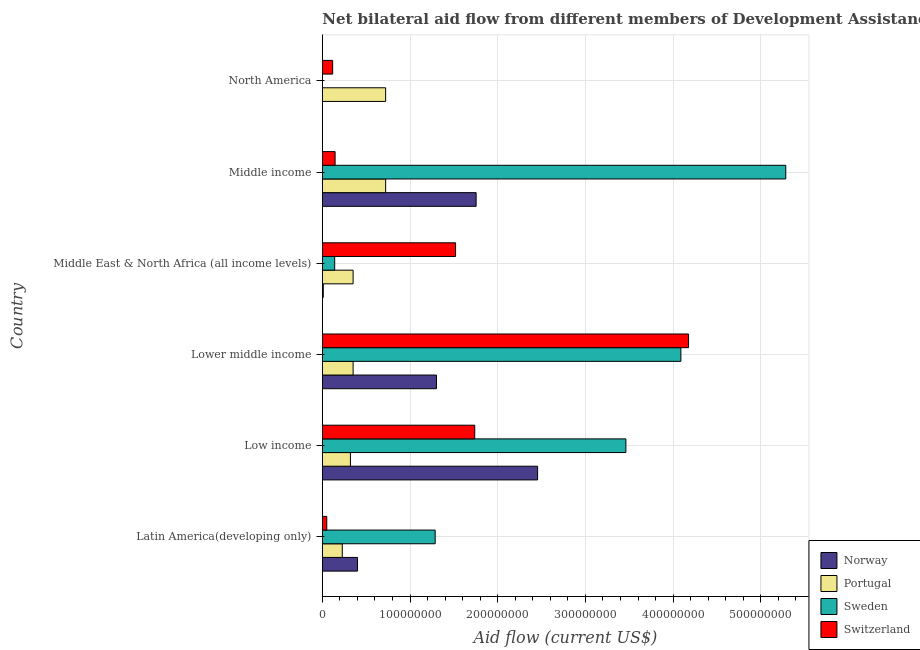How many different coloured bars are there?
Your response must be concise. 4. How many groups of bars are there?
Provide a succinct answer. 6. Are the number of bars per tick equal to the number of legend labels?
Your response must be concise. No. Are the number of bars on each tick of the Y-axis equal?
Keep it short and to the point. No. How many bars are there on the 2nd tick from the top?
Keep it short and to the point. 4. What is the label of the 4th group of bars from the top?
Make the answer very short. Lower middle income. What is the amount of aid given by switzerland in Lower middle income?
Provide a short and direct response. 4.18e+08. Across all countries, what is the maximum amount of aid given by portugal?
Offer a terse response. 7.22e+07. Across all countries, what is the minimum amount of aid given by portugal?
Ensure brevity in your answer.  2.28e+07. In which country was the amount of aid given by norway maximum?
Offer a very short reply. Low income. What is the total amount of aid given by norway in the graph?
Offer a terse response. 5.92e+08. What is the difference between the amount of aid given by portugal in Middle East & North Africa (all income levels) and that in North America?
Your answer should be very brief. -3.71e+07. What is the difference between the amount of aid given by switzerland in Middle income and the amount of aid given by norway in Low income?
Provide a short and direct response. -2.31e+08. What is the average amount of aid given by portugal per country?
Offer a very short reply. 4.49e+07. What is the difference between the amount of aid given by sweden and amount of aid given by switzerland in Middle East & North Africa (all income levels)?
Keep it short and to the point. -1.38e+08. In how many countries, is the amount of aid given by switzerland greater than 440000000 US$?
Provide a succinct answer. 0. What is the ratio of the amount of aid given by switzerland in Latin America(developing only) to that in Lower middle income?
Your answer should be compact. 0.01. Is the amount of aid given by portugal in Lower middle income less than that in Middle East & North Africa (all income levels)?
Provide a succinct answer. No. What is the difference between the highest and the second highest amount of aid given by switzerland?
Your answer should be compact. 2.44e+08. What is the difference between the highest and the lowest amount of aid given by norway?
Your answer should be very brief. 2.45e+08. In how many countries, is the amount of aid given by sweden greater than the average amount of aid given by sweden taken over all countries?
Provide a succinct answer. 3. Is it the case that in every country, the sum of the amount of aid given by norway and amount of aid given by portugal is greater than the amount of aid given by sweden?
Offer a terse response. No. Does the graph contain any zero values?
Make the answer very short. Yes. Does the graph contain grids?
Provide a succinct answer. Yes. What is the title of the graph?
Make the answer very short. Net bilateral aid flow from different members of Development Assistance Committee in the year 1989. Does "Forest" appear as one of the legend labels in the graph?
Your response must be concise. No. What is the label or title of the X-axis?
Your answer should be compact. Aid flow (current US$). What is the label or title of the Y-axis?
Your response must be concise. Country. What is the Aid flow (current US$) in Norway in Latin America(developing only)?
Ensure brevity in your answer.  4.01e+07. What is the Aid flow (current US$) in Portugal in Latin America(developing only)?
Your response must be concise. 2.28e+07. What is the Aid flow (current US$) in Sweden in Latin America(developing only)?
Give a very brief answer. 1.29e+08. What is the Aid flow (current US$) in Switzerland in Latin America(developing only)?
Provide a succinct answer. 5.06e+06. What is the Aid flow (current US$) in Norway in Low income?
Your answer should be very brief. 2.45e+08. What is the Aid flow (current US$) in Portugal in Low income?
Offer a very short reply. 3.21e+07. What is the Aid flow (current US$) in Sweden in Low income?
Your answer should be compact. 3.46e+08. What is the Aid flow (current US$) in Switzerland in Low income?
Provide a succinct answer. 1.74e+08. What is the Aid flow (current US$) in Norway in Lower middle income?
Provide a short and direct response. 1.30e+08. What is the Aid flow (current US$) of Portugal in Lower middle income?
Ensure brevity in your answer.  3.51e+07. What is the Aid flow (current US$) of Sweden in Lower middle income?
Provide a succinct answer. 4.09e+08. What is the Aid flow (current US$) of Switzerland in Lower middle income?
Offer a very short reply. 4.18e+08. What is the Aid flow (current US$) of Norway in Middle East & North Africa (all income levels)?
Ensure brevity in your answer.  1.06e+06. What is the Aid flow (current US$) of Portugal in Middle East & North Africa (all income levels)?
Ensure brevity in your answer.  3.51e+07. What is the Aid flow (current US$) of Sweden in Middle East & North Africa (all income levels)?
Provide a succinct answer. 1.41e+07. What is the Aid flow (current US$) of Switzerland in Middle East & North Africa (all income levels)?
Your answer should be very brief. 1.52e+08. What is the Aid flow (current US$) of Norway in Middle income?
Offer a very short reply. 1.75e+08. What is the Aid flow (current US$) of Portugal in Middle income?
Provide a short and direct response. 7.22e+07. What is the Aid flow (current US$) of Sweden in Middle income?
Provide a succinct answer. 5.29e+08. What is the Aid flow (current US$) of Switzerland in Middle income?
Give a very brief answer. 1.46e+07. What is the Aid flow (current US$) of Norway in North America?
Offer a very short reply. 3.00e+04. What is the Aid flow (current US$) in Portugal in North America?
Your answer should be very brief. 7.22e+07. What is the Aid flow (current US$) in Switzerland in North America?
Keep it short and to the point. 1.18e+07. Across all countries, what is the maximum Aid flow (current US$) in Norway?
Provide a succinct answer. 2.45e+08. Across all countries, what is the maximum Aid flow (current US$) of Portugal?
Provide a short and direct response. 7.22e+07. Across all countries, what is the maximum Aid flow (current US$) in Sweden?
Offer a terse response. 5.29e+08. Across all countries, what is the maximum Aid flow (current US$) of Switzerland?
Your response must be concise. 4.18e+08. Across all countries, what is the minimum Aid flow (current US$) of Norway?
Make the answer very short. 3.00e+04. Across all countries, what is the minimum Aid flow (current US$) in Portugal?
Your answer should be very brief. 2.28e+07. Across all countries, what is the minimum Aid flow (current US$) in Sweden?
Provide a short and direct response. 0. Across all countries, what is the minimum Aid flow (current US$) in Switzerland?
Keep it short and to the point. 5.06e+06. What is the total Aid flow (current US$) in Norway in the graph?
Offer a very short reply. 5.92e+08. What is the total Aid flow (current US$) in Portugal in the graph?
Make the answer very short. 2.69e+08. What is the total Aid flow (current US$) in Sweden in the graph?
Provide a succinct answer. 1.43e+09. What is the total Aid flow (current US$) in Switzerland in the graph?
Give a very brief answer. 7.75e+08. What is the difference between the Aid flow (current US$) in Norway in Latin America(developing only) and that in Low income?
Make the answer very short. -2.05e+08. What is the difference between the Aid flow (current US$) in Portugal in Latin America(developing only) and that in Low income?
Offer a very short reply. -9.30e+06. What is the difference between the Aid flow (current US$) of Sweden in Latin America(developing only) and that in Low income?
Provide a succinct answer. -2.17e+08. What is the difference between the Aid flow (current US$) in Switzerland in Latin America(developing only) and that in Low income?
Keep it short and to the point. -1.69e+08. What is the difference between the Aid flow (current US$) in Norway in Latin America(developing only) and that in Lower middle income?
Offer a terse response. -9.01e+07. What is the difference between the Aid flow (current US$) in Portugal in Latin America(developing only) and that in Lower middle income?
Your response must be concise. -1.23e+07. What is the difference between the Aid flow (current US$) in Sweden in Latin America(developing only) and that in Lower middle income?
Provide a short and direct response. -2.80e+08. What is the difference between the Aid flow (current US$) of Switzerland in Latin America(developing only) and that in Lower middle income?
Give a very brief answer. -4.13e+08. What is the difference between the Aid flow (current US$) of Norway in Latin America(developing only) and that in Middle East & North Africa (all income levels)?
Ensure brevity in your answer.  3.90e+07. What is the difference between the Aid flow (current US$) in Portugal in Latin America(developing only) and that in Middle East & North Africa (all income levels)?
Your answer should be compact. -1.23e+07. What is the difference between the Aid flow (current US$) of Sweden in Latin America(developing only) and that in Middle East & North Africa (all income levels)?
Make the answer very short. 1.15e+08. What is the difference between the Aid flow (current US$) of Switzerland in Latin America(developing only) and that in Middle East & North Africa (all income levels)?
Provide a succinct answer. -1.47e+08. What is the difference between the Aid flow (current US$) of Norway in Latin America(developing only) and that in Middle income?
Give a very brief answer. -1.35e+08. What is the difference between the Aid flow (current US$) in Portugal in Latin America(developing only) and that in Middle income?
Give a very brief answer. -4.94e+07. What is the difference between the Aid flow (current US$) in Sweden in Latin America(developing only) and that in Middle income?
Ensure brevity in your answer.  -4.00e+08. What is the difference between the Aid flow (current US$) of Switzerland in Latin America(developing only) and that in Middle income?
Offer a very short reply. -9.50e+06. What is the difference between the Aid flow (current US$) in Norway in Latin America(developing only) and that in North America?
Offer a terse response. 4.01e+07. What is the difference between the Aid flow (current US$) of Portugal in Latin America(developing only) and that in North America?
Provide a succinct answer. -4.94e+07. What is the difference between the Aid flow (current US$) in Switzerland in Latin America(developing only) and that in North America?
Make the answer very short. -6.72e+06. What is the difference between the Aid flow (current US$) in Norway in Low income and that in Lower middle income?
Provide a short and direct response. 1.15e+08. What is the difference between the Aid flow (current US$) of Portugal in Low income and that in Lower middle income?
Your answer should be very brief. -3.04e+06. What is the difference between the Aid flow (current US$) of Sweden in Low income and that in Lower middle income?
Your answer should be compact. -6.27e+07. What is the difference between the Aid flow (current US$) of Switzerland in Low income and that in Lower middle income?
Offer a terse response. -2.44e+08. What is the difference between the Aid flow (current US$) in Norway in Low income and that in Middle East & North Africa (all income levels)?
Offer a terse response. 2.44e+08. What is the difference between the Aid flow (current US$) in Portugal in Low income and that in Middle East & North Africa (all income levels)?
Ensure brevity in your answer.  -3.04e+06. What is the difference between the Aid flow (current US$) of Sweden in Low income and that in Middle East & North Africa (all income levels)?
Provide a succinct answer. 3.32e+08. What is the difference between the Aid flow (current US$) of Switzerland in Low income and that in Middle East & North Africa (all income levels)?
Provide a succinct answer. 2.18e+07. What is the difference between the Aid flow (current US$) of Norway in Low income and that in Middle income?
Offer a very short reply. 7.01e+07. What is the difference between the Aid flow (current US$) in Portugal in Low income and that in Middle income?
Your response must be concise. -4.01e+07. What is the difference between the Aid flow (current US$) of Sweden in Low income and that in Middle income?
Offer a terse response. -1.82e+08. What is the difference between the Aid flow (current US$) of Switzerland in Low income and that in Middle income?
Keep it short and to the point. 1.59e+08. What is the difference between the Aid flow (current US$) of Norway in Low income and that in North America?
Ensure brevity in your answer.  2.45e+08. What is the difference between the Aid flow (current US$) of Portugal in Low income and that in North America?
Provide a short and direct response. -4.01e+07. What is the difference between the Aid flow (current US$) in Switzerland in Low income and that in North America?
Keep it short and to the point. 1.62e+08. What is the difference between the Aid flow (current US$) in Norway in Lower middle income and that in Middle East & North Africa (all income levels)?
Provide a short and direct response. 1.29e+08. What is the difference between the Aid flow (current US$) in Sweden in Lower middle income and that in Middle East & North Africa (all income levels)?
Your answer should be compact. 3.95e+08. What is the difference between the Aid flow (current US$) of Switzerland in Lower middle income and that in Middle East & North Africa (all income levels)?
Ensure brevity in your answer.  2.66e+08. What is the difference between the Aid flow (current US$) of Norway in Lower middle income and that in Middle income?
Offer a very short reply. -4.52e+07. What is the difference between the Aid flow (current US$) in Portugal in Lower middle income and that in Middle income?
Offer a terse response. -3.71e+07. What is the difference between the Aid flow (current US$) of Sweden in Lower middle income and that in Middle income?
Provide a short and direct response. -1.20e+08. What is the difference between the Aid flow (current US$) in Switzerland in Lower middle income and that in Middle income?
Provide a short and direct response. 4.03e+08. What is the difference between the Aid flow (current US$) of Norway in Lower middle income and that in North America?
Your response must be concise. 1.30e+08. What is the difference between the Aid flow (current US$) of Portugal in Lower middle income and that in North America?
Provide a short and direct response. -3.71e+07. What is the difference between the Aid flow (current US$) of Switzerland in Lower middle income and that in North America?
Your answer should be compact. 4.06e+08. What is the difference between the Aid flow (current US$) of Norway in Middle East & North Africa (all income levels) and that in Middle income?
Provide a succinct answer. -1.74e+08. What is the difference between the Aid flow (current US$) of Portugal in Middle East & North Africa (all income levels) and that in Middle income?
Offer a very short reply. -3.71e+07. What is the difference between the Aid flow (current US$) in Sweden in Middle East & North Africa (all income levels) and that in Middle income?
Ensure brevity in your answer.  -5.14e+08. What is the difference between the Aid flow (current US$) of Switzerland in Middle East & North Africa (all income levels) and that in Middle income?
Give a very brief answer. 1.37e+08. What is the difference between the Aid flow (current US$) of Norway in Middle East & North Africa (all income levels) and that in North America?
Your answer should be very brief. 1.03e+06. What is the difference between the Aid flow (current US$) in Portugal in Middle East & North Africa (all income levels) and that in North America?
Your answer should be very brief. -3.71e+07. What is the difference between the Aid flow (current US$) in Switzerland in Middle East & North Africa (all income levels) and that in North America?
Your response must be concise. 1.40e+08. What is the difference between the Aid flow (current US$) in Norway in Middle income and that in North America?
Offer a terse response. 1.75e+08. What is the difference between the Aid flow (current US$) of Portugal in Middle income and that in North America?
Give a very brief answer. 0. What is the difference between the Aid flow (current US$) of Switzerland in Middle income and that in North America?
Your response must be concise. 2.78e+06. What is the difference between the Aid flow (current US$) in Norway in Latin America(developing only) and the Aid flow (current US$) in Portugal in Low income?
Offer a very short reply. 8.04e+06. What is the difference between the Aid flow (current US$) in Norway in Latin America(developing only) and the Aid flow (current US$) in Sweden in Low income?
Offer a terse response. -3.06e+08. What is the difference between the Aid flow (current US$) of Norway in Latin America(developing only) and the Aid flow (current US$) of Switzerland in Low income?
Your response must be concise. -1.34e+08. What is the difference between the Aid flow (current US$) of Portugal in Latin America(developing only) and the Aid flow (current US$) of Sweden in Low income?
Provide a succinct answer. -3.23e+08. What is the difference between the Aid flow (current US$) in Portugal in Latin America(developing only) and the Aid flow (current US$) in Switzerland in Low income?
Your answer should be compact. -1.51e+08. What is the difference between the Aid flow (current US$) in Sweden in Latin America(developing only) and the Aid flow (current US$) in Switzerland in Low income?
Give a very brief answer. -4.51e+07. What is the difference between the Aid flow (current US$) of Norway in Latin America(developing only) and the Aid flow (current US$) of Sweden in Lower middle income?
Offer a terse response. -3.69e+08. What is the difference between the Aid flow (current US$) in Norway in Latin America(developing only) and the Aid flow (current US$) in Switzerland in Lower middle income?
Offer a terse response. -3.78e+08. What is the difference between the Aid flow (current US$) of Portugal in Latin America(developing only) and the Aid flow (current US$) of Sweden in Lower middle income?
Your response must be concise. -3.86e+08. What is the difference between the Aid flow (current US$) in Portugal in Latin America(developing only) and the Aid flow (current US$) in Switzerland in Lower middle income?
Your answer should be very brief. -3.95e+08. What is the difference between the Aid flow (current US$) of Sweden in Latin America(developing only) and the Aid flow (current US$) of Switzerland in Lower middle income?
Your answer should be very brief. -2.89e+08. What is the difference between the Aid flow (current US$) in Norway in Latin America(developing only) and the Aid flow (current US$) in Sweden in Middle East & North Africa (all income levels)?
Provide a succinct answer. 2.60e+07. What is the difference between the Aid flow (current US$) in Norway in Latin America(developing only) and the Aid flow (current US$) in Switzerland in Middle East & North Africa (all income levels)?
Provide a succinct answer. -1.12e+08. What is the difference between the Aid flow (current US$) of Portugal in Latin America(developing only) and the Aid flow (current US$) of Sweden in Middle East & North Africa (all income levels)?
Provide a short and direct response. 8.66e+06. What is the difference between the Aid flow (current US$) of Portugal in Latin America(developing only) and the Aid flow (current US$) of Switzerland in Middle East & North Africa (all income levels)?
Your answer should be compact. -1.29e+08. What is the difference between the Aid flow (current US$) of Sweden in Latin America(developing only) and the Aid flow (current US$) of Switzerland in Middle East & North Africa (all income levels)?
Offer a terse response. -2.33e+07. What is the difference between the Aid flow (current US$) in Norway in Latin America(developing only) and the Aid flow (current US$) in Portugal in Middle income?
Keep it short and to the point. -3.21e+07. What is the difference between the Aid flow (current US$) in Norway in Latin America(developing only) and the Aid flow (current US$) in Sweden in Middle income?
Your response must be concise. -4.88e+08. What is the difference between the Aid flow (current US$) of Norway in Latin America(developing only) and the Aid flow (current US$) of Switzerland in Middle income?
Make the answer very short. 2.55e+07. What is the difference between the Aid flow (current US$) of Portugal in Latin America(developing only) and the Aid flow (current US$) of Sweden in Middle income?
Keep it short and to the point. -5.06e+08. What is the difference between the Aid flow (current US$) of Portugal in Latin America(developing only) and the Aid flow (current US$) of Switzerland in Middle income?
Offer a terse response. 8.20e+06. What is the difference between the Aid flow (current US$) of Sweden in Latin America(developing only) and the Aid flow (current US$) of Switzerland in Middle income?
Offer a terse response. 1.14e+08. What is the difference between the Aid flow (current US$) in Norway in Latin America(developing only) and the Aid flow (current US$) in Portugal in North America?
Keep it short and to the point. -3.21e+07. What is the difference between the Aid flow (current US$) of Norway in Latin America(developing only) and the Aid flow (current US$) of Switzerland in North America?
Make the answer very short. 2.83e+07. What is the difference between the Aid flow (current US$) of Portugal in Latin America(developing only) and the Aid flow (current US$) of Switzerland in North America?
Ensure brevity in your answer.  1.10e+07. What is the difference between the Aid flow (current US$) in Sweden in Latin America(developing only) and the Aid flow (current US$) in Switzerland in North America?
Ensure brevity in your answer.  1.17e+08. What is the difference between the Aid flow (current US$) in Norway in Low income and the Aid flow (current US$) in Portugal in Lower middle income?
Make the answer very short. 2.10e+08. What is the difference between the Aid flow (current US$) in Norway in Low income and the Aid flow (current US$) in Sweden in Lower middle income?
Offer a terse response. -1.63e+08. What is the difference between the Aid flow (current US$) of Norway in Low income and the Aid flow (current US$) of Switzerland in Lower middle income?
Your response must be concise. -1.72e+08. What is the difference between the Aid flow (current US$) of Portugal in Low income and the Aid flow (current US$) of Sweden in Lower middle income?
Keep it short and to the point. -3.77e+08. What is the difference between the Aid flow (current US$) in Portugal in Low income and the Aid flow (current US$) in Switzerland in Lower middle income?
Ensure brevity in your answer.  -3.86e+08. What is the difference between the Aid flow (current US$) in Sweden in Low income and the Aid flow (current US$) in Switzerland in Lower middle income?
Provide a short and direct response. -7.15e+07. What is the difference between the Aid flow (current US$) of Norway in Low income and the Aid flow (current US$) of Portugal in Middle East & North Africa (all income levels)?
Provide a succinct answer. 2.10e+08. What is the difference between the Aid flow (current US$) in Norway in Low income and the Aid flow (current US$) in Sweden in Middle East & North Africa (all income levels)?
Ensure brevity in your answer.  2.31e+08. What is the difference between the Aid flow (current US$) of Norway in Low income and the Aid flow (current US$) of Switzerland in Middle East & North Africa (all income levels)?
Ensure brevity in your answer.  9.35e+07. What is the difference between the Aid flow (current US$) of Portugal in Low income and the Aid flow (current US$) of Sweden in Middle East & North Africa (all income levels)?
Offer a terse response. 1.80e+07. What is the difference between the Aid flow (current US$) of Portugal in Low income and the Aid flow (current US$) of Switzerland in Middle East & North Africa (all income levels)?
Keep it short and to the point. -1.20e+08. What is the difference between the Aid flow (current US$) in Sweden in Low income and the Aid flow (current US$) in Switzerland in Middle East & North Africa (all income levels)?
Keep it short and to the point. 1.94e+08. What is the difference between the Aid flow (current US$) in Norway in Low income and the Aid flow (current US$) in Portugal in Middle income?
Make the answer very short. 1.73e+08. What is the difference between the Aid flow (current US$) of Norway in Low income and the Aid flow (current US$) of Sweden in Middle income?
Make the answer very short. -2.83e+08. What is the difference between the Aid flow (current US$) in Norway in Low income and the Aid flow (current US$) in Switzerland in Middle income?
Your response must be concise. 2.31e+08. What is the difference between the Aid flow (current US$) in Portugal in Low income and the Aid flow (current US$) in Sweden in Middle income?
Ensure brevity in your answer.  -4.96e+08. What is the difference between the Aid flow (current US$) in Portugal in Low income and the Aid flow (current US$) in Switzerland in Middle income?
Your response must be concise. 1.75e+07. What is the difference between the Aid flow (current US$) of Sweden in Low income and the Aid flow (current US$) of Switzerland in Middle income?
Offer a terse response. 3.32e+08. What is the difference between the Aid flow (current US$) of Norway in Low income and the Aid flow (current US$) of Portugal in North America?
Keep it short and to the point. 1.73e+08. What is the difference between the Aid flow (current US$) in Norway in Low income and the Aid flow (current US$) in Switzerland in North America?
Offer a terse response. 2.34e+08. What is the difference between the Aid flow (current US$) of Portugal in Low income and the Aid flow (current US$) of Switzerland in North America?
Your answer should be compact. 2.03e+07. What is the difference between the Aid flow (current US$) in Sweden in Low income and the Aid flow (current US$) in Switzerland in North America?
Make the answer very short. 3.34e+08. What is the difference between the Aid flow (current US$) of Norway in Lower middle income and the Aid flow (current US$) of Portugal in Middle East & North Africa (all income levels)?
Ensure brevity in your answer.  9.51e+07. What is the difference between the Aid flow (current US$) in Norway in Lower middle income and the Aid flow (current US$) in Sweden in Middle East & North Africa (all income levels)?
Ensure brevity in your answer.  1.16e+08. What is the difference between the Aid flow (current US$) of Norway in Lower middle income and the Aid flow (current US$) of Switzerland in Middle East & North Africa (all income levels)?
Offer a very short reply. -2.18e+07. What is the difference between the Aid flow (current US$) in Portugal in Lower middle income and the Aid flow (current US$) in Sweden in Middle East & North Africa (all income levels)?
Your response must be concise. 2.10e+07. What is the difference between the Aid flow (current US$) of Portugal in Lower middle income and the Aid flow (current US$) of Switzerland in Middle East & North Africa (all income levels)?
Offer a very short reply. -1.17e+08. What is the difference between the Aid flow (current US$) of Sweden in Lower middle income and the Aid flow (current US$) of Switzerland in Middle East & North Africa (all income levels)?
Give a very brief answer. 2.57e+08. What is the difference between the Aid flow (current US$) of Norway in Lower middle income and the Aid flow (current US$) of Portugal in Middle income?
Ensure brevity in your answer.  5.80e+07. What is the difference between the Aid flow (current US$) in Norway in Lower middle income and the Aid flow (current US$) in Sweden in Middle income?
Offer a very short reply. -3.98e+08. What is the difference between the Aid flow (current US$) of Norway in Lower middle income and the Aid flow (current US$) of Switzerland in Middle income?
Offer a terse response. 1.16e+08. What is the difference between the Aid flow (current US$) in Portugal in Lower middle income and the Aid flow (current US$) in Sweden in Middle income?
Offer a terse response. -4.93e+08. What is the difference between the Aid flow (current US$) of Portugal in Lower middle income and the Aid flow (current US$) of Switzerland in Middle income?
Your answer should be compact. 2.05e+07. What is the difference between the Aid flow (current US$) of Sweden in Lower middle income and the Aid flow (current US$) of Switzerland in Middle income?
Provide a short and direct response. 3.94e+08. What is the difference between the Aid flow (current US$) of Norway in Lower middle income and the Aid flow (current US$) of Portugal in North America?
Your answer should be compact. 5.80e+07. What is the difference between the Aid flow (current US$) of Norway in Lower middle income and the Aid flow (current US$) of Switzerland in North America?
Offer a very short reply. 1.18e+08. What is the difference between the Aid flow (current US$) in Portugal in Lower middle income and the Aid flow (current US$) in Switzerland in North America?
Ensure brevity in your answer.  2.33e+07. What is the difference between the Aid flow (current US$) of Sweden in Lower middle income and the Aid flow (current US$) of Switzerland in North America?
Provide a short and direct response. 3.97e+08. What is the difference between the Aid flow (current US$) of Norway in Middle East & North Africa (all income levels) and the Aid flow (current US$) of Portugal in Middle income?
Provide a succinct answer. -7.11e+07. What is the difference between the Aid flow (current US$) of Norway in Middle East & North Africa (all income levels) and the Aid flow (current US$) of Sweden in Middle income?
Offer a very short reply. -5.27e+08. What is the difference between the Aid flow (current US$) in Norway in Middle East & North Africa (all income levels) and the Aid flow (current US$) in Switzerland in Middle income?
Your answer should be very brief. -1.35e+07. What is the difference between the Aid flow (current US$) in Portugal in Middle East & North Africa (all income levels) and the Aid flow (current US$) in Sweden in Middle income?
Your answer should be compact. -4.93e+08. What is the difference between the Aid flow (current US$) of Portugal in Middle East & North Africa (all income levels) and the Aid flow (current US$) of Switzerland in Middle income?
Ensure brevity in your answer.  2.05e+07. What is the difference between the Aid flow (current US$) in Sweden in Middle East & North Africa (all income levels) and the Aid flow (current US$) in Switzerland in Middle income?
Offer a terse response. -4.60e+05. What is the difference between the Aid flow (current US$) of Norway in Middle East & North Africa (all income levels) and the Aid flow (current US$) of Portugal in North America?
Your answer should be compact. -7.11e+07. What is the difference between the Aid flow (current US$) of Norway in Middle East & North Africa (all income levels) and the Aid flow (current US$) of Switzerland in North America?
Your response must be concise. -1.07e+07. What is the difference between the Aid flow (current US$) of Portugal in Middle East & North Africa (all income levels) and the Aid flow (current US$) of Switzerland in North America?
Ensure brevity in your answer.  2.33e+07. What is the difference between the Aid flow (current US$) of Sweden in Middle East & North Africa (all income levels) and the Aid flow (current US$) of Switzerland in North America?
Give a very brief answer. 2.32e+06. What is the difference between the Aid flow (current US$) in Norway in Middle income and the Aid flow (current US$) in Portugal in North America?
Offer a terse response. 1.03e+08. What is the difference between the Aid flow (current US$) in Norway in Middle income and the Aid flow (current US$) in Switzerland in North America?
Make the answer very short. 1.64e+08. What is the difference between the Aid flow (current US$) in Portugal in Middle income and the Aid flow (current US$) in Switzerland in North America?
Your response must be concise. 6.04e+07. What is the difference between the Aid flow (current US$) in Sweden in Middle income and the Aid flow (current US$) in Switzerland in North America?
Your answer should be compact. 5.17e+08. What is the average Aid flow (current US$) of Norway per country?
Offer a very short reply. 9.87e+07. What is the average Aid flow (current US$) of Portugal per country?
Offer a very short reply. 4.49e+07. What is the average Aid flow (current US$) in Sweden per country?
Your response must be concise. 2.38e+08. What is the average Aid flow (current US$) of Switzerland per country?
Keep it short and to the point. 1.29e+08. What is the difference between the Aid flow (current US$) in Norway and Aid flow (current US$) in Portugal in Latin America(developing only)?
Offer a very short reply. 1.73e+07. What is the difference between the Aid flow (current US$) in Norway and Aid flow (current US$) in Sweden in Latin America(developing only)?
Provide a short and direct response. -8.86e+07. What is the difference between the Aid flow (current US$) of Norway and Aid flow (current US$) of Switzerland in Latin America(developing only)?
Give a very brief answer. 3.50e+07. What is the difference between the Aid flow (current US$) in Portugal and Aid flow (current US$) in Sweden in Latin America(developing only)?
Ensure brevity in your answer.  -1.06e+08. What is the difference between the Aid flow (current US$) of Portugal and Aid flow (current US$) of Switzerland in Latin America(developing only)?
Offer a very short reply. 1.77e+07. What is the difference between the Aid flow (current US$) of Sweden and Aid flow (current US$) of Switzerland in Latin America(developing only)?
Provide a short and direct response. 1.24e+08. What is the difference between the Aid flow (current US$) of Norway and Aid flow (current US$) of Portugal in Low income?
Your response must be concise. 2.13e+08. What is the difference between the Aid flow (current US$) in Norway and Aid flow (current US$) in Sweden in Low income?
Provide a succinct answer. -1.01e+08. What is the difference between the Aid flow (current US$) of Norway and Aid flow (current US$) of Switzerland in Low income?
Make the answer very short. 7.17e+07. What is the difference between the Aid flow (current US$) in Portugal and Aid flow (current US$) in Sweden in Low income?
Your answer should be compact. -3.14e+08. What is the difference between the Aid flow (current US$) of Portugal and Aid flow (current US$) of Switzerland in Low income?
Provide a short and direct response. -1.42e+08. What is the difference between the Aid flow (current US$) of Sweden and Aid flow (current US$) of Switzerland in Low income?
Your response must be concise. 1.72e+08. What is the difference between the Aid flow (current US$) in Norway and Aid flow (current US$) in Portugal in Lower middle income?
Keep it short and to the point. 9.51e+07. What is the difference between the Aid flow (current US$) of Norway and Aid flow (current US$) of Sweden in Lower middle income?
Offer a terse response. -2.79e+08. What is the difference between the Aid flow (current US$) in Norway and Aid flow (current US$) in Switzerland in Lower middle income?
Keep it short and to the point. -2.87e+08. What is the difference between the Aid flow (current US$) of Portugal and Aid flow (current US$) of Sweden in Lower middle income?
Keep it short and to the point. -3.74e+08. What is the difference between the Aid flow (current US$) in Portugal and Aid flow (current US$) in Switzerland in Lower middle income?
Provide a short and direct response. -3.83e+08. What is the difference between the Aid flow (current US$) of Sweden and Aid flow (current US$) of Switzerland in Lower middle income?
Provide a short and direct response. -8.76e+06. What is the difference between the Aid flow (current US$) in Norway and Aid flow (current US$) in Portugal in Middle East & North Africa (all income levels)?
Ensure brevity in your answer.  -3.40e+07. What is the difference between the Aid flow (current US$) in Norway and Aid flow (current US$) in Sweden in Middle East & North Africa (all income levels)?
Provide a short and direct response. -1.30e+07. What is the difference between the Aid flow (current US$) in Norway and Aid flow (current US$) in Switzerland in Middle East & North Africa (all income levels)?
Your answer should be very brief. -1.51e+08. What is the difference between the Aid flow (current US$) in Portugal and Aid flow (current US$) in Sweden in Middle East & North Africa (all income levels)?
Make the answer very short. 2.10e+07. What is the difference between the Aid flow (current US$) of Portugal and Aid flow (current US$) of Switzerland in Middle East & North Africa (all income levels)?
Make the answer very short. -1.17e+08. What is the difference between the Aid flow (current US$) in Sweden and Aid flow (current US$) in Switzerland in Middle East & North Africa (all income levels)?
Offer a terse response. -1.38e+08. What is the difference between the Aid flow (current US$) of Norway and Aid flow (current US$) of Portugal in Middle income?
Keep it short and to the point. 1.03e+08. What is the difference between the Aid flow (current US$) in Norway and Aid flow (current US$) in Sweden in Middle income?
Your response must be concise. -3.53e+08. What is the difference between the Aid flow (current US$) of Norway and Aid flow (current US$) of Switzerland in Middle income?
Your answer should be compact. 1.61e+08. What is the difference between the Aid flow (current US$) of Portugal and Aid flow (current US$) of Sweden in Middle income?
Offer a very short reply. -4.56e+08. What is the difference between the Aid flow (current US$) of Portugal and Aid flow (current US$) of Switzerland in Middle income?
Provide a succinct answer. 5.76e+07. What is the difference between the Aid flow (current US$) in Sweden and Aid flow (current US$) in Switzerland in Middle income?
Give a very brief answer. 5.14e+08. What is the difference between the Aid flow (current US$) in Norway and Aid flow (current US$) in Portugal in North America?
Your answer should be very brief. -7.22e+07. What is the difference between the Aid flow (current US$) in Norway and Aid flow (current US$) in Switzerland in North America?
Your response must be concise. -1.18e+07. What is the difference between the Aid flow (current US$) in Portugal and Aid flow (current US$) in Switzerland in North America?
Provide a short and direct response. 6.04e+07. What is the ratio of the Aid flow (current US$) of Norway in Latin America(developing only) to that in Low income?
Give a very brief answer. 0.16. What is the ratio of the Aid flow (current US$) in Portugal in Latin America(developing only) to that in Low income?
Offer a very short reply. 0.71. What is the ratio of the Aid flow (current US$) in Sweden in Latin America(developing only) to that in Low income?
Make the answer very short. 0.37. What is the ratio of the Aid flow (current US$) of Switzerland in Latin America(developing only) to that in Low income?
Offer a very short reply. 0.03. What is the ratio of the Aid flow (current US$) in Norway in Latin America(developing only) to that in Lower middle income?
Your answer should be very brief. 0.31. What is the ratio of the Aid flow (current US$) of Portugal in Latin America(developing only) to that in Lower middle income?
Your response must be concise. 0.65. What is the ratio of the Aid flow (current US$) in Sweden in Latin America(developing only) to that in Lower middle income?
Your response must be concise. 0.31. What is the ratio of the Aid flow (current US$) of Switzerland in Latin America(developing only) to that in Lower middle income?
Your answer should be compact. 0.01. What is the ratio of the Aid flow (current US$) of Norway in Latin America(developing only) to that in Middle East & North Africa (all income levels)?
Provide a succinct answer. 37.83. What is the ratio of the Aid flow (current US$) of Portugal in Latin America(developing only) to that in Middle East & North Africa (all income levels)?
Your answer should be very brief. 0.65. What is the ratio of the Aid flow (current US$) of Sweden in Latin America(developing only) to that in Middle East & North Africa (all income levels)?
Ensure brevity in your answer.  9.13. What is the ratio of the Aid flow (current US$) of Switzerland in Latin America(developing only) to that in Middle East & North Africa (all income levels)?
Ensure brevity in your answer.  0.03. What is the ratio of the Aid flow (current US$) of Norway in Latin America(developing only) to that in Middle income?
Your answer should be compact. 0.23. What is the ratio of the Aid flow (current US$) of Portugal in Latin America(developing only) to that in Middle income?
Ensure brevity in your answer.  0.32. What is the ratio of the Aid flow (current US$) in Sweden in Latin America(developing only) to that in Middle income?
Offer a very short reply. 0.24. What is the ratio of the Aid flow (current US$) in Switzerland in Latin America(developing only) to that in Middle income?
Offer a very short reply. 0.35. What is the ratio of the Aid flow (current US$) of Norway in Latin America(developing only) to that in North America?
Make the answer very short. 1336.67. What is the ratio of the Aid flow (current US$) in Portugal in Latin America(developing only) to that in North America?
Your answer should be very brief. 0.32. What is the ratio of the Aid flow (current US$) in Switzerland in Latin America(developing only) to that in North America?
Give a very brief answer. 0.43. What is the ratio of the Aid flow (current US$) of Norway in Low income to that in Lower middle income?
Offer a very short reply. 1.89. What is the ratio of the Aid flow (current US$) of Portugal in Low income to that in Lower middle income?
Offer a terse response. 0.91. What is the ratio of the Aid flow (current US$) in Sweden in Low income to that in Lower middle income?
Provide a succinct answer. 0.85. What is the ratio of the Aid flow (current US$) of Switzerland in Low income to that in Lower middle income?
Offer a very short reply. 0.42. What is the ratio of the Aid flow (current US$) of Norway in Low income to that in Middle East & North Africa (all income levels)?
Ensure brevity in your answer.  231.59. What is the ratio of the Aid flow (current US$) in Portugal in Low income to that in Middle East & North Africa (all income levels)?
Offer a very short reply. 0.91. What is the ratio of the Aid flow (current US$) in Sweden in Low income to that in Middle East & North Africa (all income levels)?
Keep it short and to the point. 24.55. What is the ratio of the Aid flow (current US$) in Switzerland in Low income to that in Middle East & North Africa (all income levels)?
Offer a terse response. 1.14. What is the ratio of the Aid flow (current US$) in Norway in Low income to that in Middle income?
Ensure brevity in your answer.  1.4. What is the ratio of the Aid flow (current US$) of Portugal in Low income to that in Middle income?
Ensure brevity in your answer.  0.44. What is the ratio of the Aid flow (current US$) in Sweden in Low income to that in Middle income?
Make the answer very short. 0.66. What is the ratio of the Aid flow (current US$) in Switzerland in Low income to that in Middle income?
Offer a terse response. 11.94. What is the ratio of the Aid flow (current US$) of Norway in Low income to that in North America?
Provide a succinct answer. 8183. What is the ratio of the Aid flow (current US$) in Portugal in Low income to that in North America?
Your answer should be compact. 0.44. What is the ratio of the Aid flow (current US$) of Switzerland in Low income to that in North America?
Give a very brief answer. 14.75. What is the ratio of the Aid flow (current US$) in Norway in Lower middle income to that in Middle East & North Africa (all income levels)?
Offer a terse response. 122.81. What is the ratio of the Aid flow (current US$) in Portugal in Lower middle income to that in Middle East & North Africa (all income levels)?
Your response must be concise. 1. What is the ratio of the Aid flow (current US$) of Sweden in Lower middle income to that in Middle East & North Africa (all income levels)?
Your answer should be compact. 29. What is the ratio of the Aid flow (current US$) in Switzerland in Lower middle income to that in Middle East & North Africa (all income levels)?
Provide a succinct answer. 2.75. What is the ratio of the Aid flow (current US$) of Norway in Lower middle income to that in Middle income?
Provide a succinct answer. 0.74. What is the ratio of the Aid flow (current US$) of Portugal in Lower middle income to that in Middle income?
Your response must be concise. 0.49. What is the ratio of the Aid flow (current US$) of Sweden in Lower middle income to that in Middle income?
Make the answer very short. 0.77. What is the ratio of the Aid flow (current US$) of Switzerland in Lower middle income to that in Middle income?
Offer a very short reply. 28.68. What is the ratio of the Aid flow (current US$) of Norway in Lower middle income to that in North America?
Offer a very short reply. 4339.33. What is the ratio of the Aid flow (current US$) in Portugal in Lower middle income to that in North America?
Make the answer very short. 0.49. What is the ratio of the Aid flow (current US$) of Switzerland in Lower middle income to that in North America?
Offer a very short reply. 35.45. What is the ratio of the Aid flow (current US$) of Norway in Middle East & North Africa (all income levels) to that in Middle income?
Offer a terse response. 0.01. What is the ratio of the Aid flow (current US$) of Portugal in Middle East & North Africa (all income levels) to that in Middle income?
Give a very brief answer. 0.49. What is the ratio of the Aid flow (current US$) in Sweden in Middle East & North Africa (all income levels) to that in Middle income?
Provide a short and direct response. 0.03. What is the ratio of the Aid flow (current US$) in Switzerland in Middle East & North Africa (all income levels) to that in Middle income?
Make the answer very short. 10.44. What is the ratio of the Aid flow (current US$) of Norway in Middle East & North Africa (all income levels) to that in North America?
Keep it short and to the point. 35.33. What is the ratio of the Aid flow (current US$) in Portugal in Middle East & North Africa (all income levels) to that in North America?
Ensure brevity in your answer.  0.49. What is the ratio of the Aid flow (current US$) of Switzerland in Middle East & North Africa (all income levels) to that in North America?
Give a very brief answer. 12.9. What is the ratio of the Aid flow (current US$) in Norway in Middle income to that in North America?
Keep it short and to the point. 5846.67. What is the ratio of the Aid flow (current US$) in Portugal in Middle income to that in North America?
Your response must be concise. 1. What is the ratio of the Aid flow (current US$) of Switzerland in Middle income to that in North America?
Make the answer very short. 1.24. What is the difference between the highest and the second highest Aid flow (current US$) of Norway?
Your answer should be very brief. 7.01e+07. What is the difference between the highest and the second highest Aid flow (current US$) in Sweden?
Keep it short and to the point. 1.20e+08. What is the difference between the highest and the second highest Aid flow (current US$) of Switzerland?
Provide a short and direct response. 2.44e+08. What is the difference between the highest and the lowest Aid flow (current US$) of Norway?
Keep it short and to the point. 2.45e+08. What is the difference between the highest and the lowest Aid flow (current US$) in Portugal?
Ensure brevity in your answer.  4.94e+07. What is the difference between the highest and the lowest Aid flow (current US$) of Sweden?
Your answer should be compact. 5.29e+08. What is the difference between the highest and the lowest Aid flow (current US$) of Switzerland?
Provide a short and direct response. 4.13e+08. 